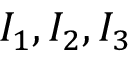Convert formula to latex. <formula><loc_0><loc_0><loc_500><loc_500>I _ { 1 } , I _ { 2 } , I _ { 3 }</formula> 